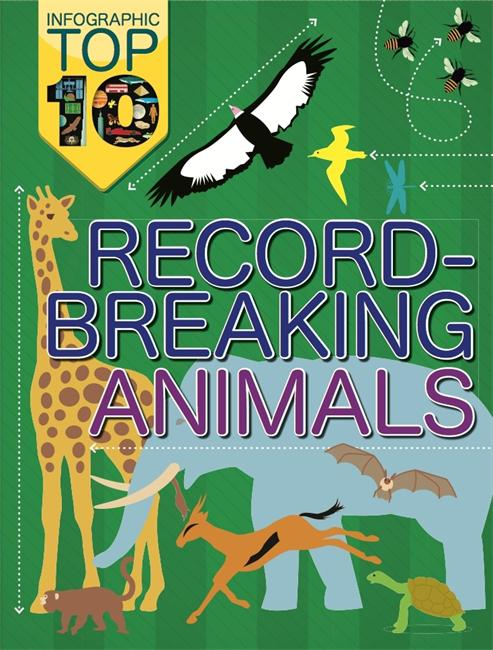What records might the giraffe in the infographic be holding? The giraffe depicted in the infographic likely holds the record for being the tallest living terrestrial animal. Its exceptional height, which can reach up to about 18 feet for males, allows it to access food sources inaccessible to other herbivores, primarily in the treetops of African savannas. 